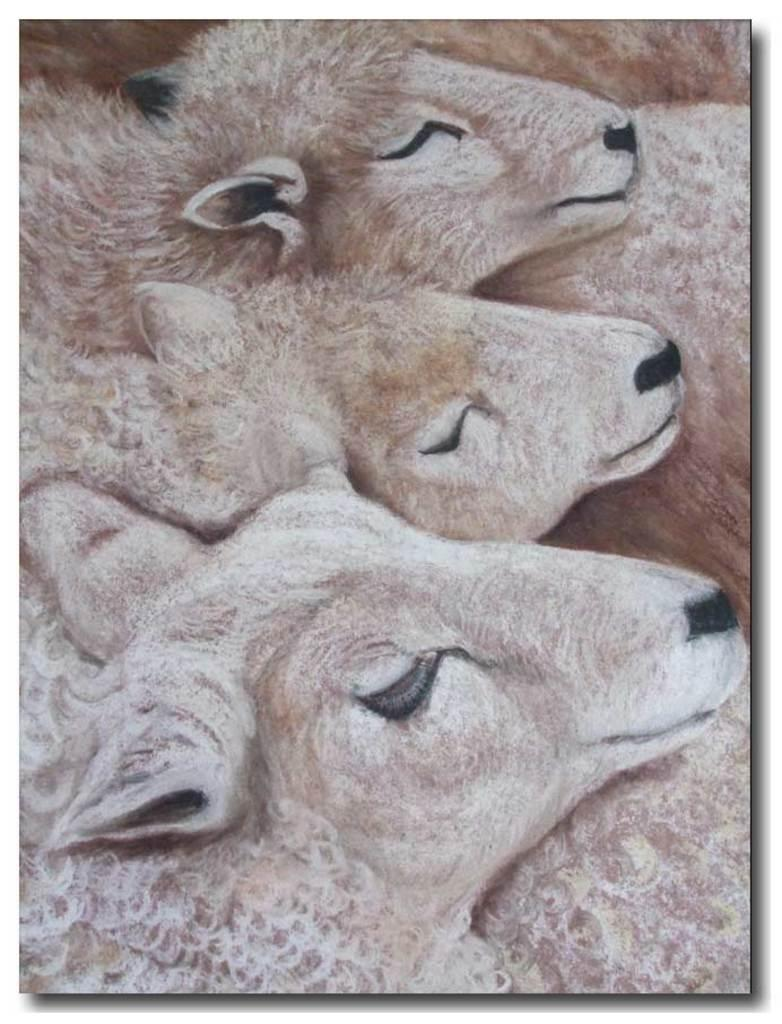What is the main subject of the image? The image contains a painting. What is depicted in the painting? The painting depicts animals. What type of health insurance is required to view the painting in the image? There is no mention of health insurance or any requirement related to it in the image. Is there any indication of a payment method for the painting in the image? There is no indication of a payment method for the painting in the image. 